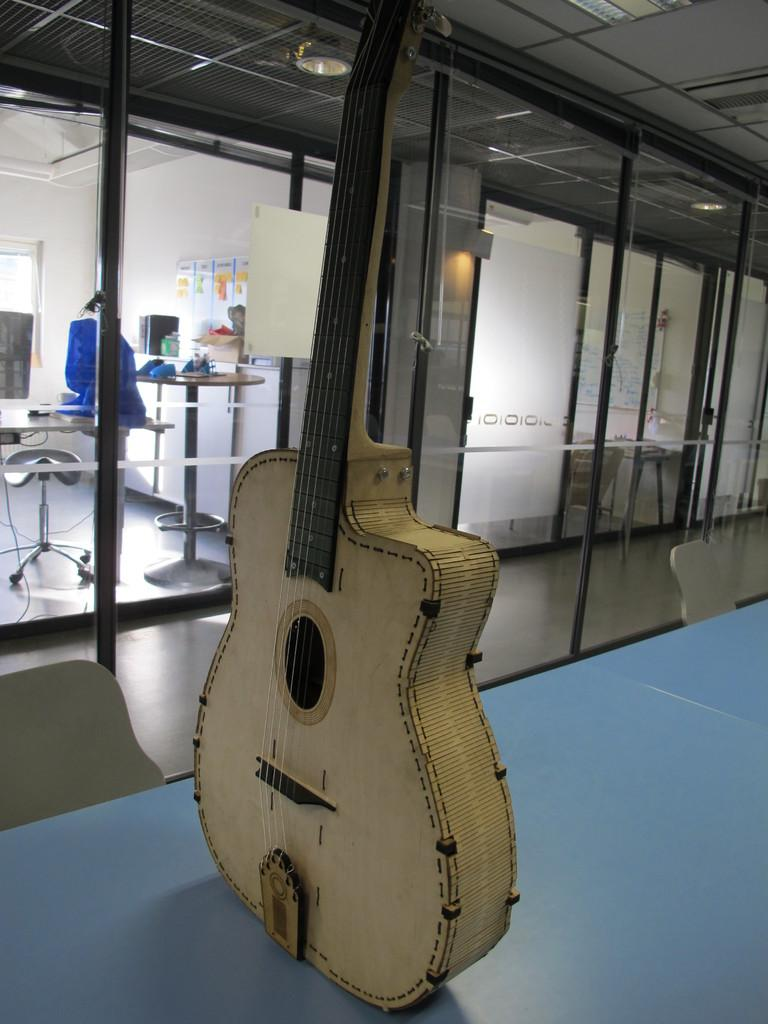What is the color of the wall in the image? The wall in the image is white. What furniture or object can be seen in the image? There is a table in the image. What musical instrument is present in the image? There is a guitar in the image. Is there any smoke coming from the guitar in the image? No, there is no smoke present in the image, and the guitar is not producing any smoke. 